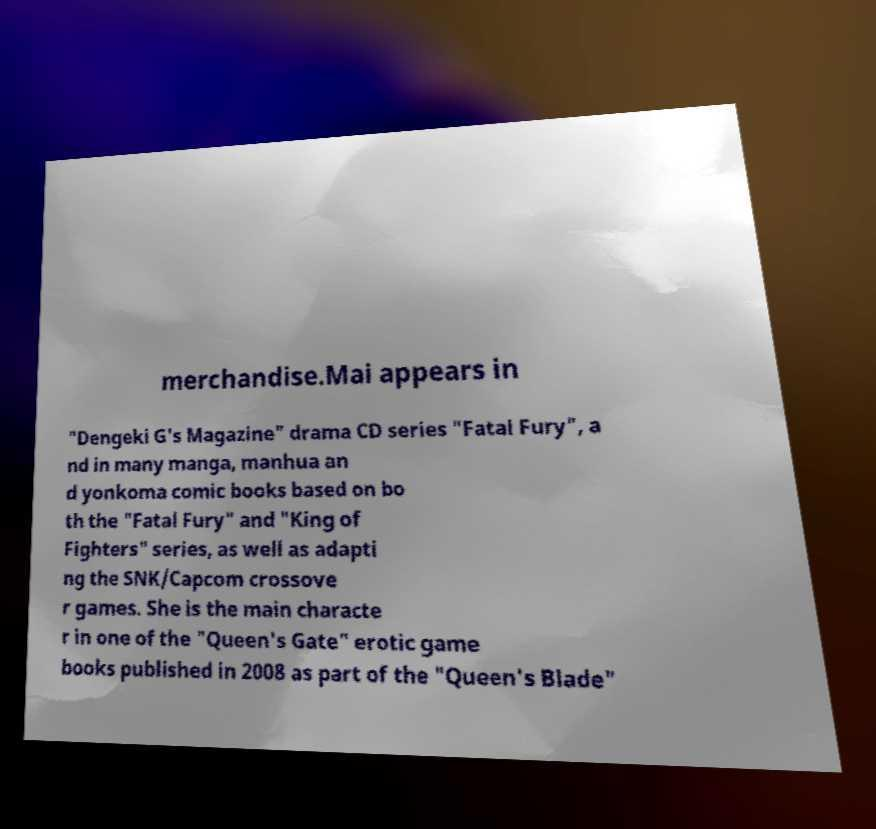Please read and relay the text visible in this image. What does it say? merchandise.Mai appears in "Dengeki G's Magazine" drama CD series "Fatal Fury", a nd in many manga, manhua an d yonkoma comic books based on bo th the "Fatal Fury" and "King of Fighters" series, as well as adapti ng the SNK/Capcom crossove r games. She is the main characte r in one of the "Queen's Gate" erotic game books published in 2008 as part of the "Queen's Blade" 